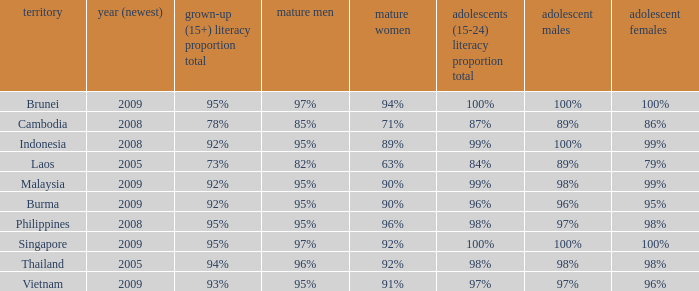What country has a Youth (15-24) Literacy Rate Total of 99%, and a Youth Men of 98%? Malaysia. 